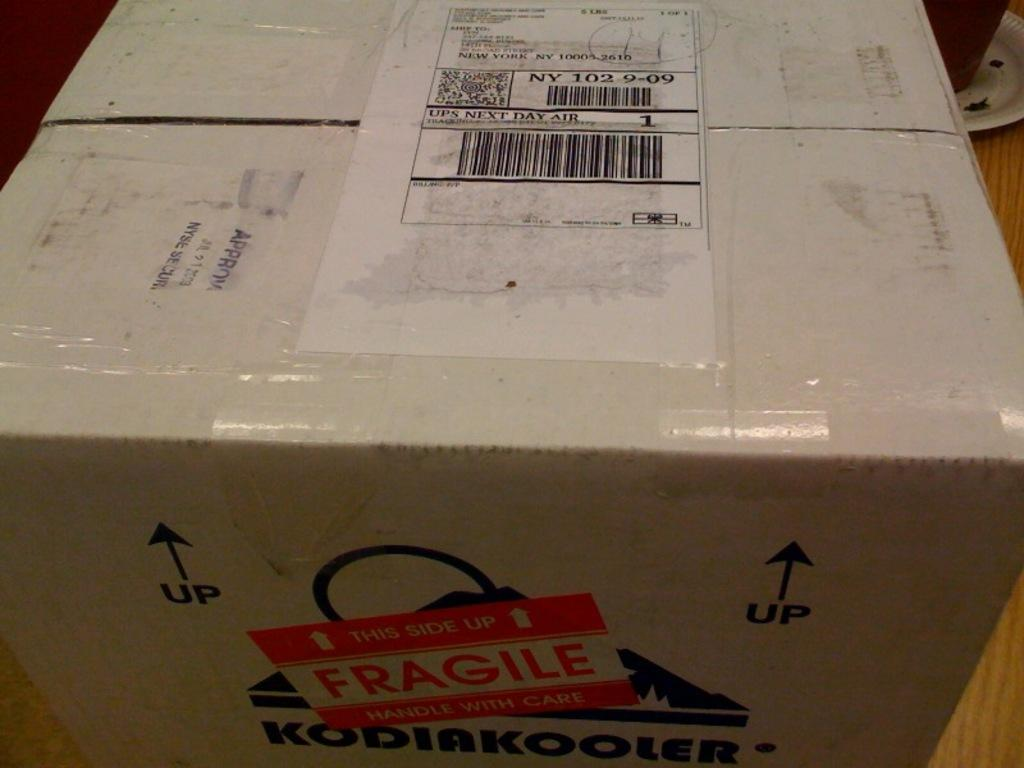<image>
Share a concise interpretation of the image provided. The person posting this box has put a fragile sticker on it. 